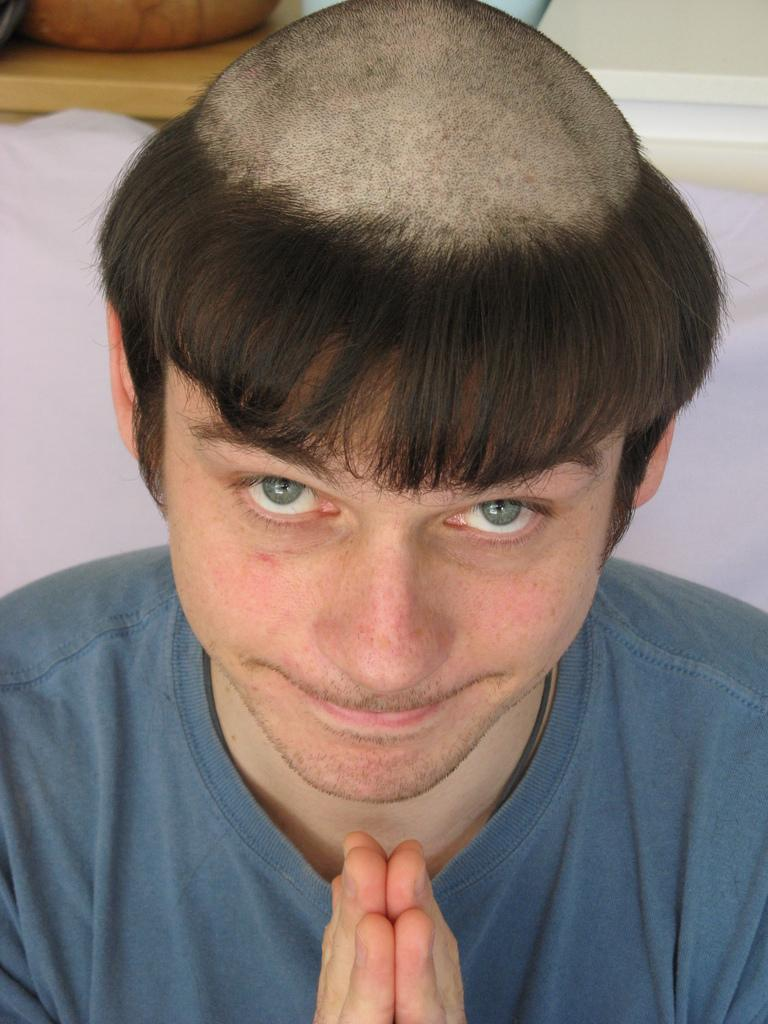What is the main subject of the image? The main subject of the image is a man. What is the man doing with his hands in the image? The man is holding his hands in the image. What type of clothing is the man wearing? The man is wearing a t-shirt in the image. Can you describe the man's hairstyle? The man's hair is cut in the image. Can you see any kites flying in the image? There are no kites visible in the image. 